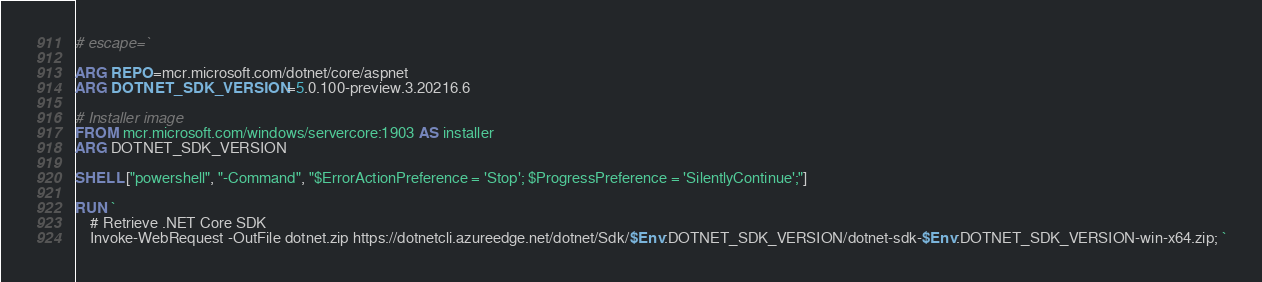<code> <loc_0><loc_0><loc_500><loc_500><_Dockerfile_># escape=`

ARG REPO=mcr.microsoft.com/dotnet/core/aspnet
ARG DOTNET_SDK_VERSION=5.0.100-preview.3.20216.6

# Installer image
FROM mcr.microsoft.com/windows/servercore:1903 AS installer
ARG DOTNET_SDK_VERSION

SHELL ["powershell", "-Command", "$ErrorActionPreference = 'Stop'; $ProgressPreference = 'SilentlyContinue';"]

RUN `
    # Retrieve .NET Core SDK
    Invoke-WebRequest -OutFile dotnet.zip https://dotnetcli.azureedge.net/dotnet/Sdk/$Env:DOTNET_SDK_VERSION/dotnet-sdk-$Env:DOTNET_SDK_VERSION-win-x64.zip; `</code> 